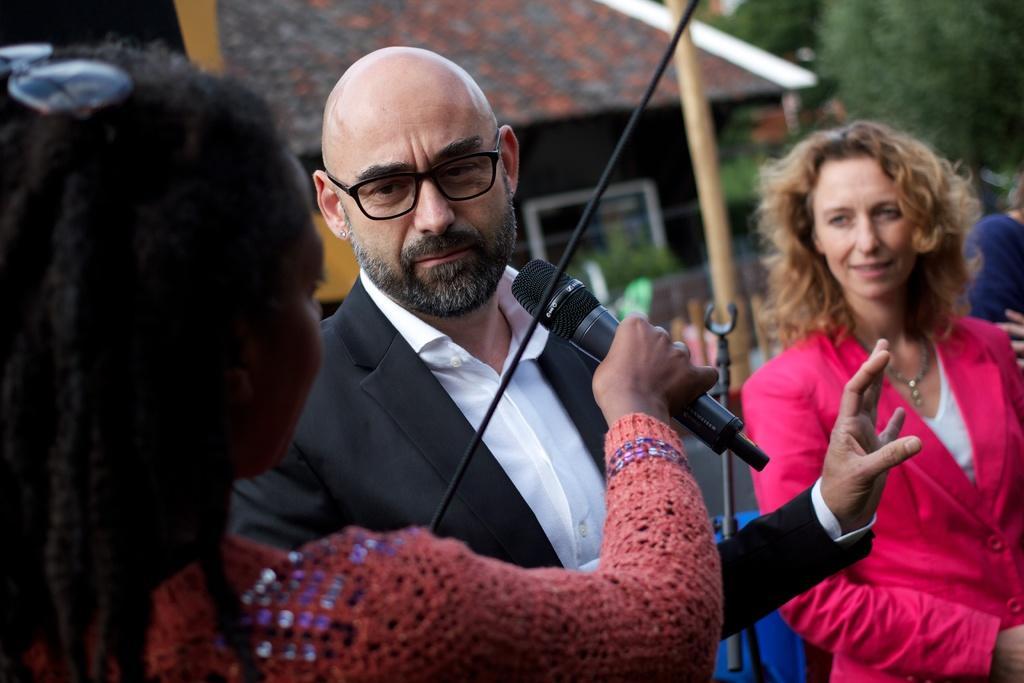Can you describe this image briefly? In this picture we can see three persons in the middle. He has spectacles and he is in black suit. She is holding a mike her hand. On the background there is a tree and this is house. And this is the pole. 